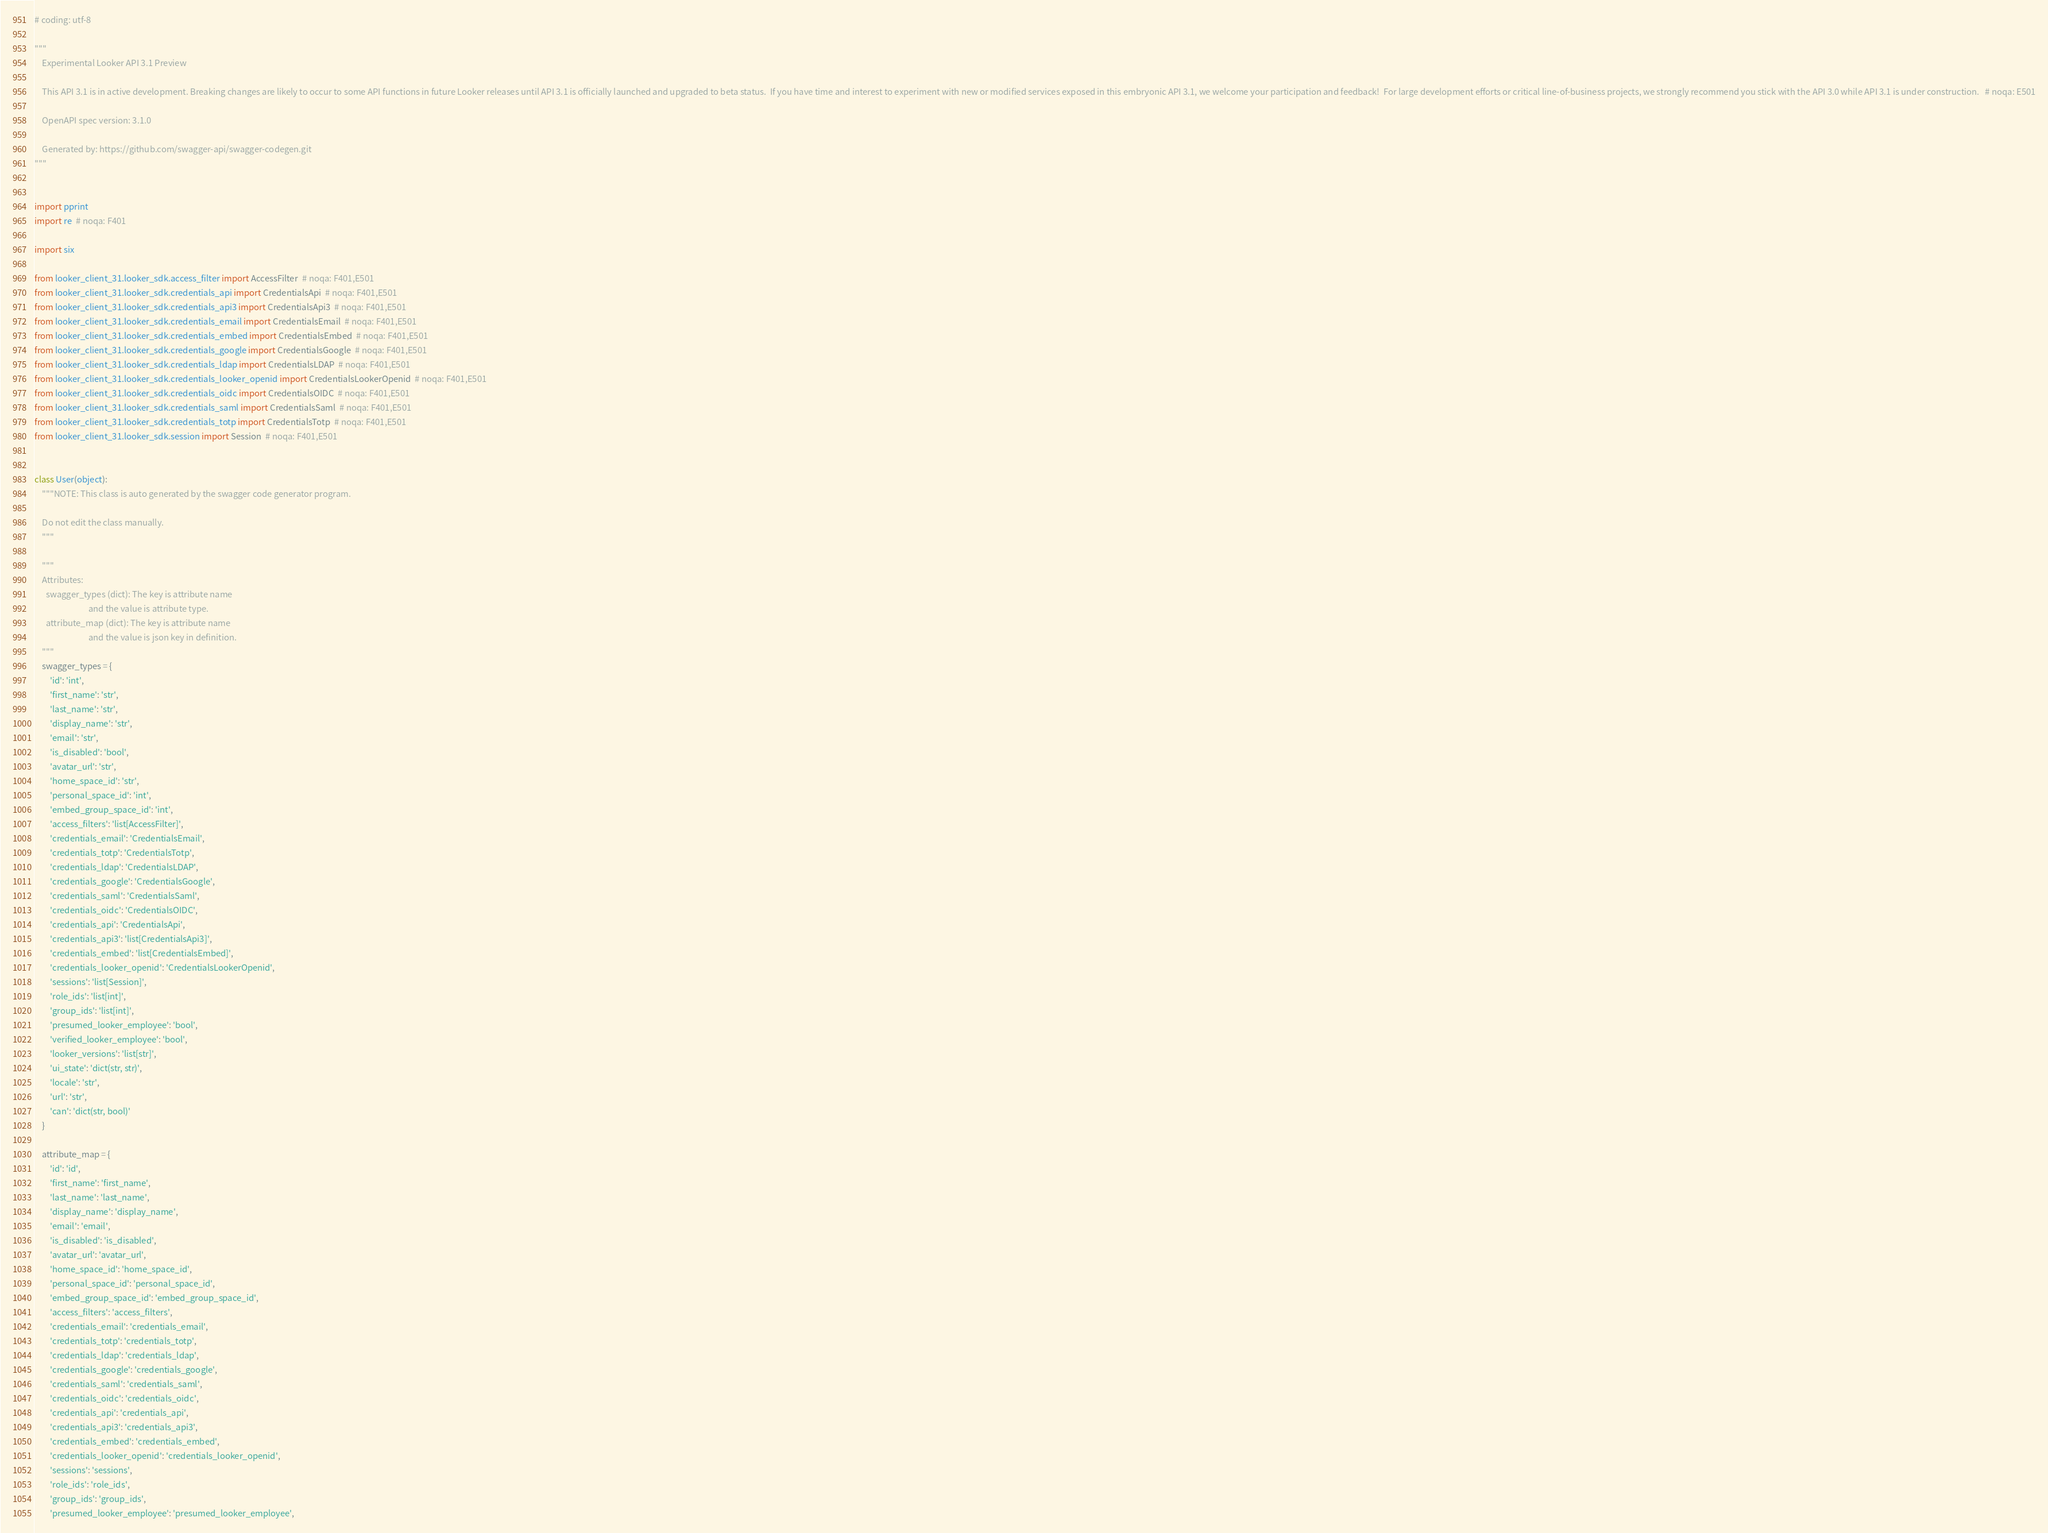Convert code to text. <code><loc_0><loc_0><loc_500><loc_500><_Python_># coding: utf-8

"""
    Experimental Looker API 3.1 Preview

    This API 3.1 is in active development. Breaking changes are likely to occur to some API functions in future Looker releases until API 3.1 is officially launched and upgraded to beta status.  If you have time and interest to experiment with new or modified services exposed in this embryonic API 3.1, we welcome your participation and feedback!  For large development efforts or critical line-of-business projects, we strongly recommend you stick with the API 3.0 while API 3.1 is under construction.   # noqa: E501

    OpenAPI spec version: 3.1.0
    
    Generated by: https://github.com/swagger-api/swagger-codegen.git
"""


import pprint
import re  # noqa: F401

import six

from looker_client_31.looker_sdk.access_filter import AccessFilter  # noqa: F401,E501
from looker_client_31.looker_sdk.credentials_api import CredentialsApi  # noqa: F401,E501
from looker_client_31.looker_sdk.credentials_api3 import CredentialsApi3  # noqa: F401,E501
from looker_client_31.looker_sdk.credentials_email import CredentialsEmail  # noqa: F401,E501
from looker_client_31.looker_sdk.credentials_embed import CredentialsEmbed  # noqa: F401,E501
from looker_client_31.looker_sdk.credentials_google import CredentialsGoogle  # noqa: F401,E501
from looker_client_31.looker_sdk.credentials_ldap import CredentialsLDAP  # noqa: F401,E501
from looker_client_31.looker_sdk.credentials_looker_openid import CredentialsLookerOpenid  # noqa: F401,E501
from looker_client_31.looker_sdk.credentials_oidc import CredentialsOIDC  # noqa: F401,E501
from looker_client_31.looker_sdk.credentials_saml import CredentialsSaml  # noqa: F401,E501
from looker_client_31.looker_sdk.credentials_totp import CredentialsTotp  # noqa: F401,E501
from looker_client_31.looker_sdk.session import Session  # noqa: F401,E501


class User(object):
    """NOTE: This class is auto generated by the swagger code generator program.

    Do not edit the class manually.
    """

    """
    Attributes:
      swagger_types (dict): The key is attribute name
                            and the value is attribute type.
      attribute_map (dict): The key is attribute name
                            and the value is json key in definition.
    """
    swagger_types = {
        'id': 'int',
        'first_name': 'str',
        'last_name': 'str',
        'display_name': 'str',
        'email': 'str',
        'is_disabled': 'bool',
        'avatar_url': 'str',
        'home_space_id': 'str',
        'personal_space_id': 'int',
        'embed_group_space_id': 'int',
        'access_filters': 'list[AccessFilter]',
        'credentials_email': 'CredentialsEmail',
        'credentials_totp': 'CredentialsTotp',
        'credentials_ldap': 'CredentialsLDAP',
        'credentials_google': 'CredentialsGoogle',
        'credentials_saml': 'CredentialsSaml',
        'credentials_oidc': 'CredentialsOIDC',
        'credentials_api': 'CredentialsApi',
        'credentials_api3': 'list[CredentialsApi3]',
        'credentials_embed': 'list[CredentialsEmbed]',
        'credentials_looker_openid': 'CredentialsLookerOpenid',
        'sessions': 'list[Session]',
        'role_ids': 'list[int]',
        'group_ids': 'list[int]',
        'presumed_looker_employee': 'bool',
        'verified_looker_employee': 'bool',
        'looker_versions': 'list[str]',
        'ui_state': 'dict(str, str)',
        'locale': 'str',
        'url': 'str',
        'can': 'dict(str, bool)'
    }

    attribute_map = {
        'id': 'id',
        'first_name': 'first_name',
        'last_name': 'last_name',
        'display_name': 'display_name',
        'email': 'email',
        'is_disabled': 'is_disabled',
        'avatar_url': 'avatar_url',
        'home_space_id': 'home_space_id',
        'personal_space_id': 'personal_space_id',
        'embed_group_space_id': 'embed_group_space_id',
        'access_filters': 'access_filters',
        'credentials_email': 'credentials_email',
        'credentials_totp': 'credentials_totp',
        'credentials_ldap': 'credentials_ldap',
        'credentials_google': 'credentials_google',
        'credentials_saml': 'credentials_saml',
        'credentials_oidc': 'credentials_oidc',
        'credentials_api': 'credentials_api',
        'credentials_api3': 'credentials_api3',
        'credentials_embed': 'credentials_embed',
        'credentials_looker_openid': 'credentials_looker_openid',
        'sessions': 'sessions',
        'role_ids': 'role_ids',
        'group_ids': 'group_ids',
        'presumed_looker_employee': 'presumed_looker_employee',</code> 